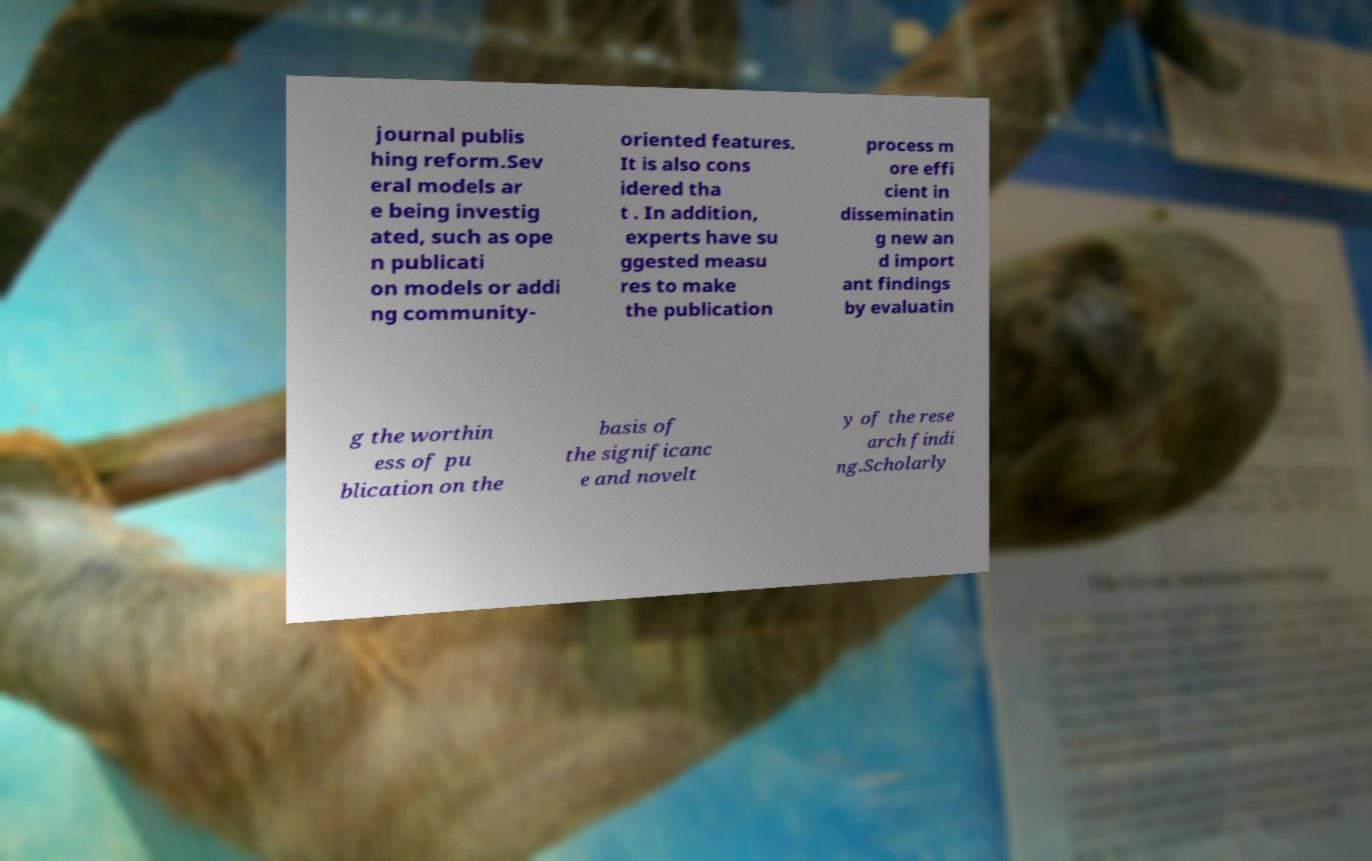Could you assist in decoding the text presented in this image and type it out clearly? journal publis hing reform.Sev eral models ar e being investig ated, such as ope n publicati on models or addi ng community- oriented features. It is also cons idered tha t . In addition, experts have su ggested measu res to make the publication process m ore effi cient in disseminatin g new an d import ant findings by evaluatin g the worthin ess of pu blication on the basis of the significanc e and novelt y of the rese arch findi ng.Scholarly 